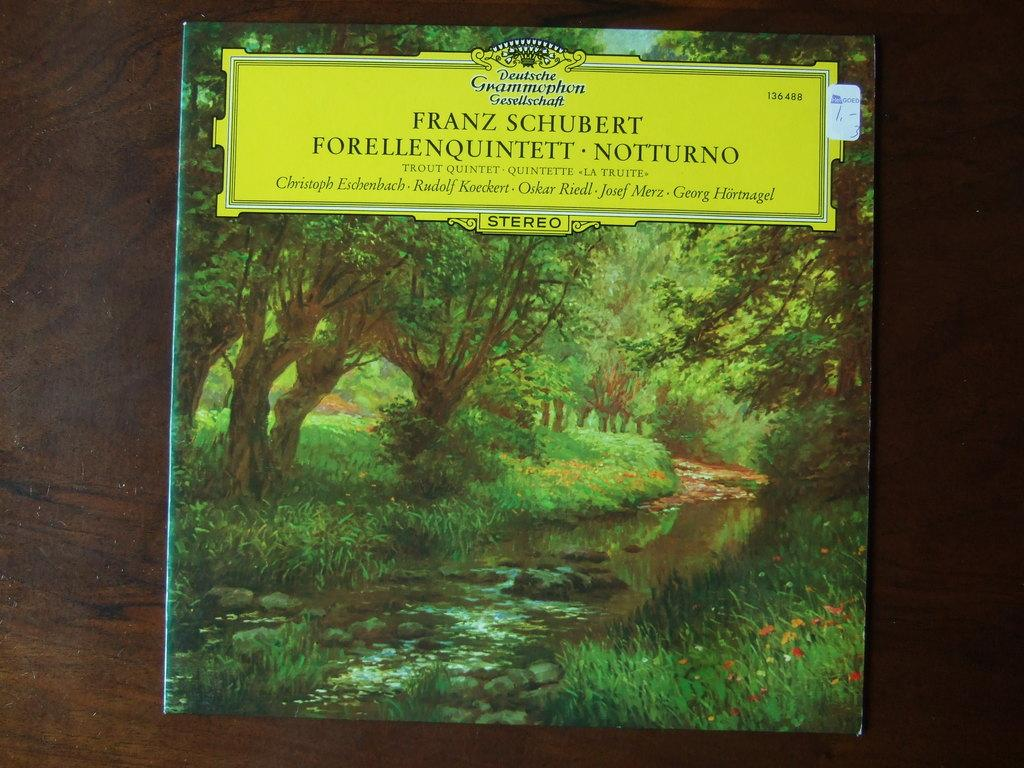What is on the poster in the image? There is text on the poster in the image. What type of natural environment is depicted in the image? Trees, grass, and water are visible in the image, indicating a natural environment. What type of surface is the poster placed on? The poster is placed on a wooden surface. What other objects can be seen in the image? Stones and flowers are present in the image. What type of cup is being used to draw on the poster in the image? There is no cup present in the image, and the poster is not being drawn on. 